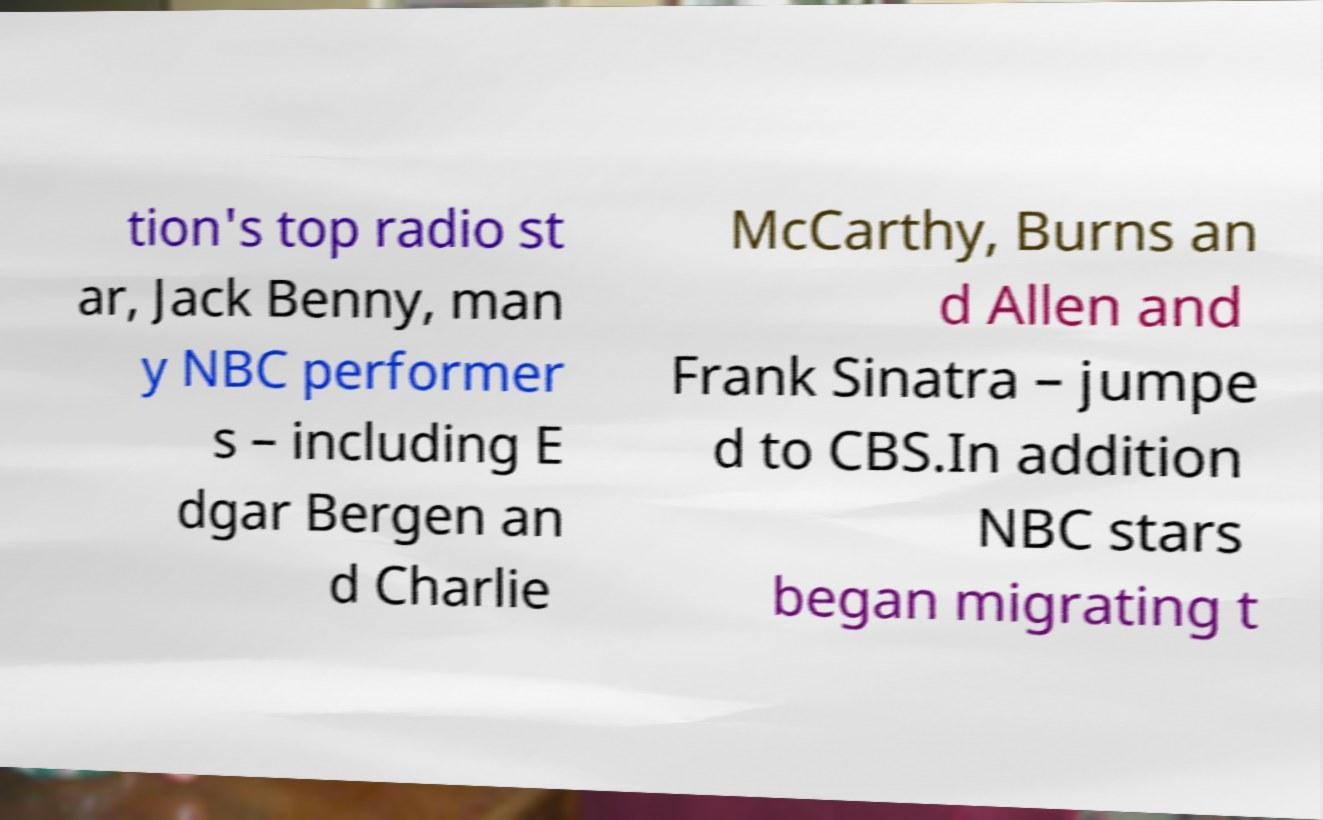For documentation purposes, I need the text within this image transcribed. Could you provide that? tion's top radio st ar, Jack Benny, man y NBC performer s – including E dgar Bergen an d Charlie McCarthy, Burns an d Allen and Frank Sinatra – jumpe d to CBS.In addition NBC stars began migrating t 